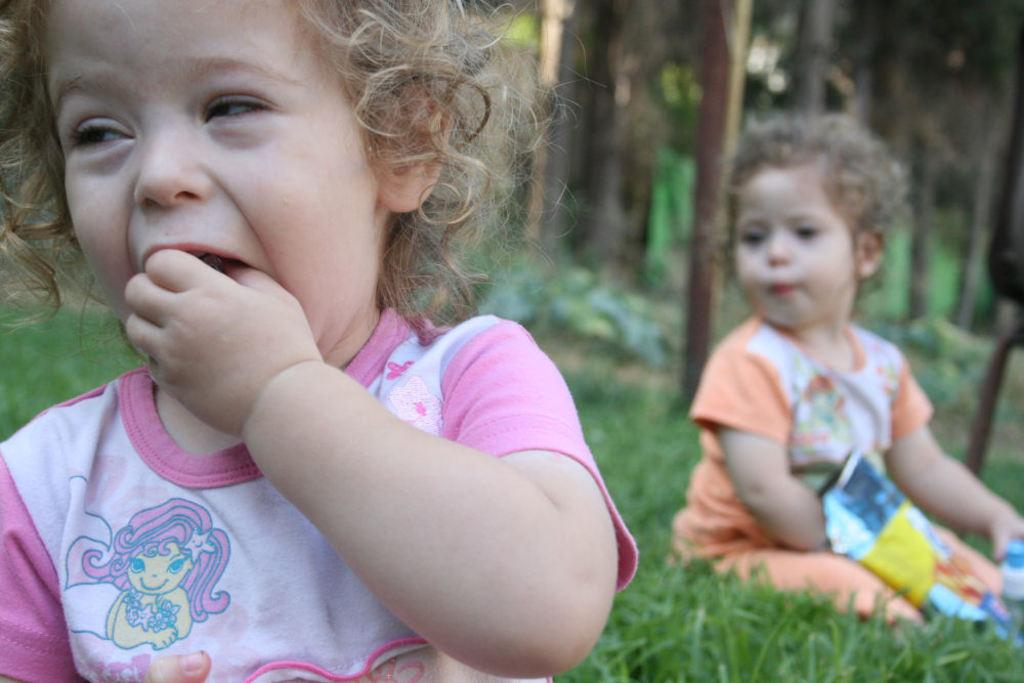How many kids are present in the image? There are two kids in the image. What are the kids doing in the image? The kids are sitting on the grass. What can be seen in the background of the image? There are trees in the background of the image. What type of friction can be observed between the kids and the grass in the image? There is no specific type of friction mentioned or observable in the image; it simply shows the kids sitting on the grass. 